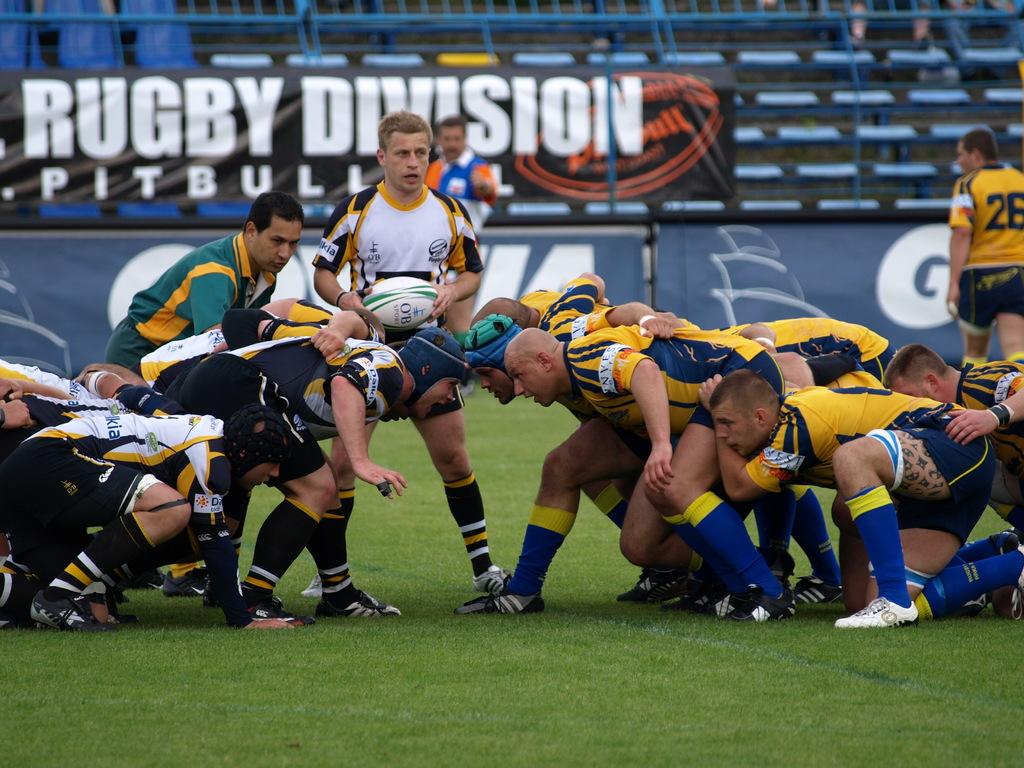What type of sport is being played indicated by the sign in the back?
Provide a succinct answer. Rugby. 